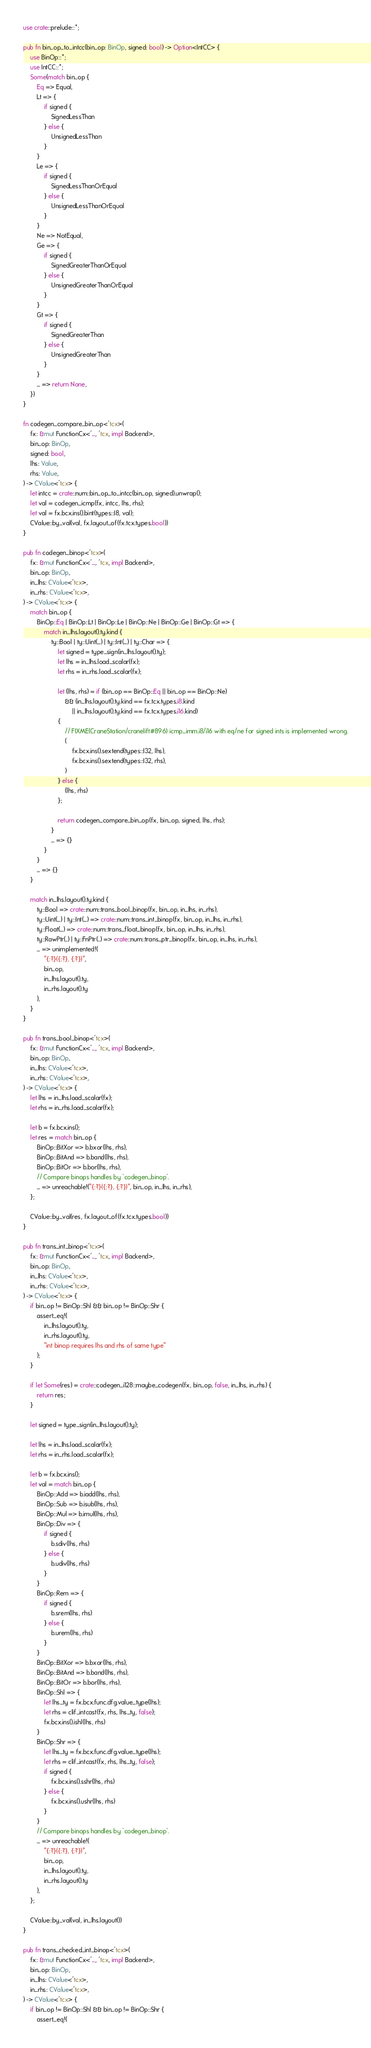Convert code to text. <code><loc_0><loc_0><loc_500><loc_500><_Rust_>use crate::prelude::*;

pub fn bin_op_to_intcc(bin_op: BinOp, signed: bool) -> Option<IntCC> {
    use BinOp::*;
    use IntCC::*;
    Some(match bin_op {
        Eq => Equal,
        Lt => {
            if signed {
                SignedLessThan
            } else {
                UnsignedLessThan
            }
        }
        Le => {
            if signed {
                SignedLessThanOrEqual
            } else {
                UnsignedLessThanOrEqual
            }
        }
        Ne => NotEqual,
        Ge => {
            if signed {
                SignedGreaterThanOrEqual
            } else {
                UnsignedGreaterThanOrEqual
            }
        }
        Gt => {
            if signed {
                SignedGreaterThan
            } else {
                UnsignedGreaterThan
            }
        }
        _ => return None,
    })
}

fn codegen_compare_bin_op<'tcx>(
    fx: &mut FunctionCx<'_, 'tcx, impl Backend>,
    bin_op: BinOp,
    signed: bool,
    lhs: Value,
    rhs: Value,
) -> CValue<'tcx> {
    let intcc = crate::num::bin_op_to_intcc(bin_op, signed).unwrap();
    let val = codegen_icmp(fx, intcc, lhs, rhs);
    let val = fx.bcx.ins().bint(types::I8, val);
    CValue::by_val(val, fx.layout_of(fx.tcx.types.bool))
}

pub fn codegen_binop<'tcx>(
    fx: &mut FunctionCx<'_, 'tcx, impl Backend>,
    bin_op: BinOp,
    in_lhs: CValue<'tcx>,
    in_rhs: CValue<'tcx>,
) -> CValue<'tcx> {
    match bin_op {
        BinOp::Eq | BinOp::Lt | BinOp::Le | BinOp::Ne | BinOp::Ge | BinOp::Gt => {
            match in_lhs.layout().ty.kind {
                ty::Bool | ty::Uint(_) | ty::Int(_) | ty::Char => {
                    let signed = type_sign(in_lhs.layout().ty);
                    let lhs = in_lhs.load_scalar(fx);
                    let rhs = in_rhs.load_scalar(fx);

                    let (lhs, rhs) = if (bin_op == BinOp::Eq || bin_op == BinOp::Ne)
                        && (in_lhs.layout().ty.kind == fx.tcx.types.i8.kind
                            || in_lhs.layout().ty.kind == fx.tcx.types.i16.kind)
                    {
                        // FIXME(CraneStation/cranelift#896) icmp_imm.i8/i16 with eq/ne for signed ints is implemented wrong.
                        (
                            fx.bcx.ins().sextend(types::I32, lhs),
                            fx.bcx.ins().sextend(types::I32, rhs),
                        )
                    } else {
                        (lhs, rhs)
                    };

                    return codegen_compare_bin_op(fx, bin_op, signed, lhs, rhs);
                }
                _ => {}
            }
        }
        _ => {}
    }

    match in_lhs.layout().ty.kind {
        ty::Bool => crate::num::trans_bool_binop(fx, bin_op, in_lhs, in_rhs),
        ty::Uint(_) | ty::Int(_) => crate::num::trans_int_binop(fx, bin_op, in_lhs, in_rhs),
        ty::Float(_) => crate::num::trans_float_binop(fx, bin_op, in_lhs, in_rhs),
        ty::RawPtr(..) | ty::FnPtr(..) => crate::num::trans_ptr_binop(fx, bin_op, in_lhs, in_rhs),
        _ => unimplemented!(
            "{:?}({:?}, {:?})",
            bin_op,
            in_lhs.layout().ty,
            in_rhs.layout().ty
        ),
    }
}

pub fn trans_bool_binop<'tcx>(
    fx: &mut FunctionCx<'_, 'tcx, impl Backend>,
    bin_op: BinOp,
    in_lhs: CValue<'tcx>,
    in_rhs: CValue<'tcx>,
) -> CValue<'tcx> {
    let lhs = in_lhs.load_scalar(fx);
    let rhs = in_rhs.load_scalar(fx);

    let b = fx.bcx.ins();
    let res = match bin_op {
        BinOp::BitXor => b.bxor(lhs, rhs),
        BinOp::BitAnd => b.band(lhs, rhs),
        BinOp::BitOr => b.bor(lhs, rhs),
        // Compare binops handles by `codegen_binop`.
        _ => unreachable!("{:?}({:?}, {:?})", bin_op, in_lhs, in_rhs),
    };

    CValue::by_val(res, fx.layout_of(fx.tcx.types.bool))
}

pub fn trans_int_binop<'tcx>(
    fx: &mut FunctionCx<'_, 'tcx, impl Backend>,
    bin_op: BinOp,
    in_lhs: CValue<'tcx>,
    in_rhs: CValue<'tcx>,
) -> CValue<'tcx> {
    if bin_op != BinOp::Shl && bin_op != BinOp::Shr {
        assert_eq!(
            in_lhs.layout().ty,
            in_rhs.layout().ty,
            "int binop requires lhs and rhs of same type"
        );
    }

    if let Some(res) = crate::codegen_i128::maybe_codegen(fx, bin_op, false, in_lhs, in_rhs) {
        return res;
    }

    let signed = type_sign(in_lhs.layout().ty);

    let lhs = in_lhs.load_scalar(fx);
    let rhs = in_rhs.load_scalar(fx);

    let b = fx.bcx.ins();
    let val = match bin_op {
        BinOp::Add => b.iadd(lhs, rhs),
        BinOp::Sub => b.isub(lhs, rhs),
        BinOp::Mul => b.imul(lhs, rhs),
        BinOp::Div => {
            if signed {
                b.sdiv(lhs, rhs)
            } else {
                b.udiv(lhs, rhs)
            }
        }
        BinOp::Rem => {
            if signed {
                b.srem(lhs, rhs)
            } else {
                b.urem(lhs, rhs)
            }
        }
        BinOp::BitXor => b.bxor(lhs, rhs),
        BinOp::BitAnd => b.band(lhs, rhs),
        BinOp::BitOr => b.bor(lhs, rhs),
        BinOp::Shl => {
            let lhs_ty = fx.bcx.func.dfg.value_type(lhs);
            let rhs = clif_intcast(fx, rhs, lhs_ty, false);
            fx.bcx.ins().ishl(lhs, rhs)
        }
        BinOp::Shr => {
            let lhs_ty = fx.bcx.func.dfg.value_type(lhs);
            let rhs = clif_intcast(fx, rhs, lhs_ty, false);
            if signed {
                fx.bcx.ins().sshr(lhs, rhs)
            } else {
                fx.bcx.ins().ushr(lhs, rhs)
            }
        }
        // Compare binops handles by `codegen_binop`.
        _ => unreachable!(
            "{:?}({:?}, {:?})",
            bin_op,
            in_lhs.layout().ty,
            in_rhs.layout().ty
        ),
    };

    CValue::by_val(val, in_lhs.layout())
}

pub fn trans_checked_int_binop<'tcx>(
    fx: &mut FunctionCx<'_, 'tcx, impl Backend>,
    bin_op: BinOp,
    in_lhs: CValue<'tcx>,
    in_rhs: CValue<'tcx>,
) -> CValue<'tcx> {
    if bin_op != BinOp::Shl && bin_op != BinOp::Shr {
        assert_eq!(</code> 